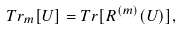<formula> <loc_0><loc_0><loc_500><loc_500>T r _ { m } [ U ] = T r [ R ^ { ( m ) } ( U ) ] ,</formula> 